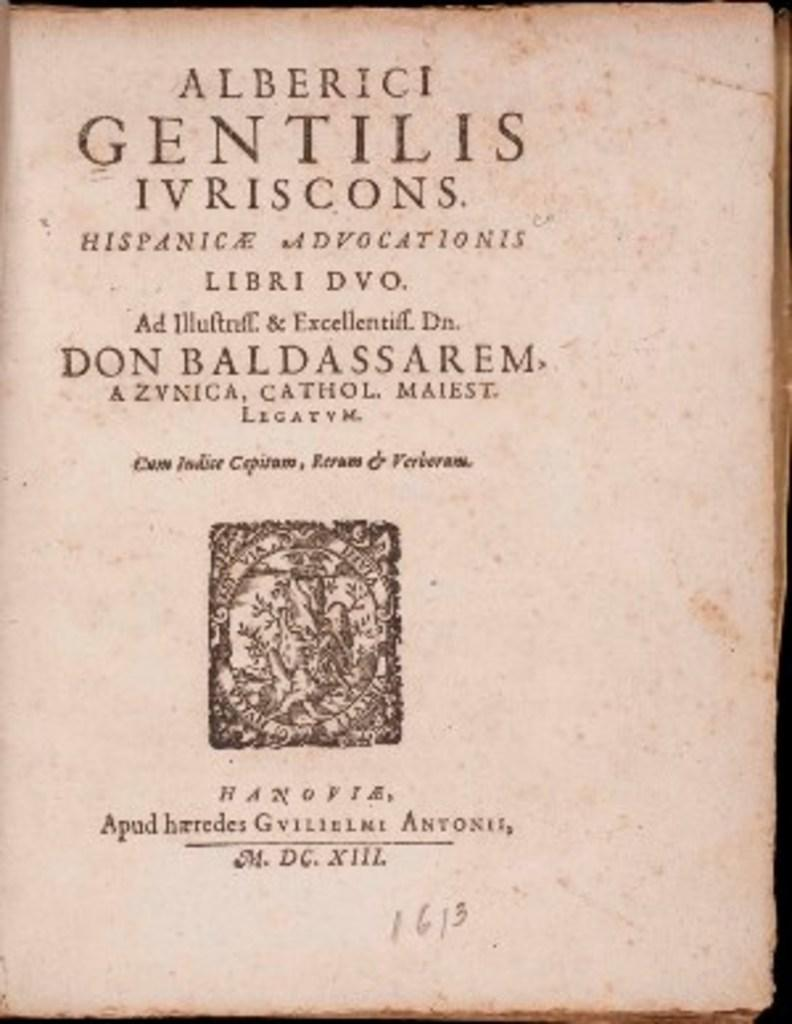<image>
Create a compact narrative representing the image presented. A book written by Alberici Gentilis Ivriscons and Don Baldassarem. 